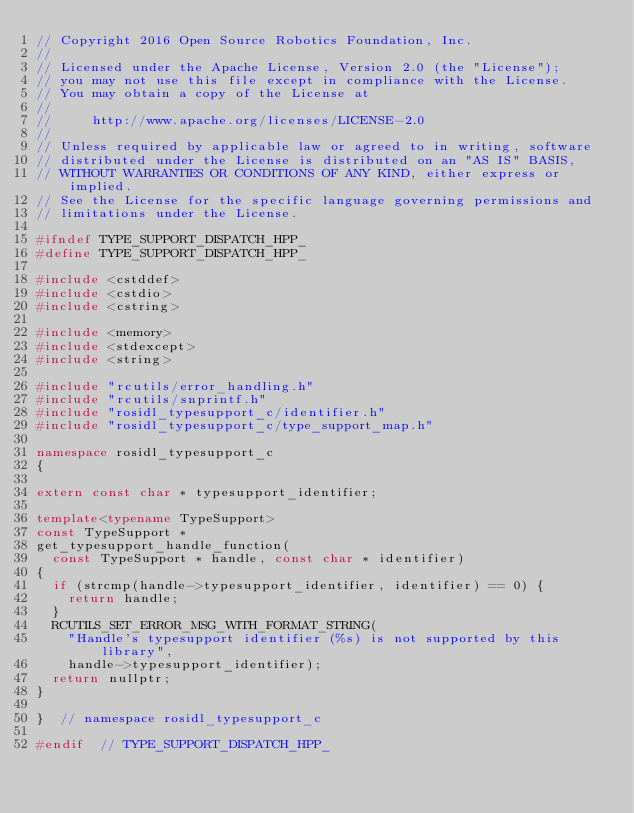Convert code to text. <code><loc_0><loc_0><loc_500><loc_500><_C++_>// Copyright 2016 Open Source Robotics Foundation, Inc.
//
// Licensed under the Apache License, Version 2.0 (the "License");
// you may not use this file except in compliance with the License.
// You may obtain a copy of the License at
//
//     http://www.apache.org/licenses/LICENSE-2.0
//
// Unless required by applicable law or agreed to in writing, software
// distributed under the License is distributed on an "AS IS" BASIS,
// WITHOUT WARRANTIES OR CONDITIONS OF ANY KIND, either express or implied.
// See the License for the specific language governing permissions and
// limitations under the License.

#ifndef TYPE_SUPPORT_DISPATCH_HPP_
#define TYPE_SUPPORT_DISPATCH_HPP_

#include <cstddef>
#include <cstdio>
#include <cstring>

#include <memory>
#include <stdexcept>
#include <string>

#include "rcutils/error_handling.h"
#include "rcutils/snprintf.h"
#include "rosidl_typesupport_c/identifier.h"
#include "rosidl_typesupport_c/type_support_map.h"

namespace rosidl_typesupport_c
{

extern const char * typesupport_identifier;

template<typename TypeSupport>
const TypeSupport *
get_typesupport_handle_function(
  const TypeSupport * handle, const char * identifier)
{
  if (strcmp(handle->typesupport_identifier, identifier) == 0) {
    return handle;
  }
  RCUTILS_SET_ERROR_MSG_WITH_FORMAT_STRING(
    "Handle's typesupport identifier (%s) is not supported by this library",
    handle->typesupport_identifier);
  return nullptr;
}

}  // namespace rosidl_typesupport_c

#endif  // TYPE_SUPPORT_DISPATCH_HPP_
</code> 